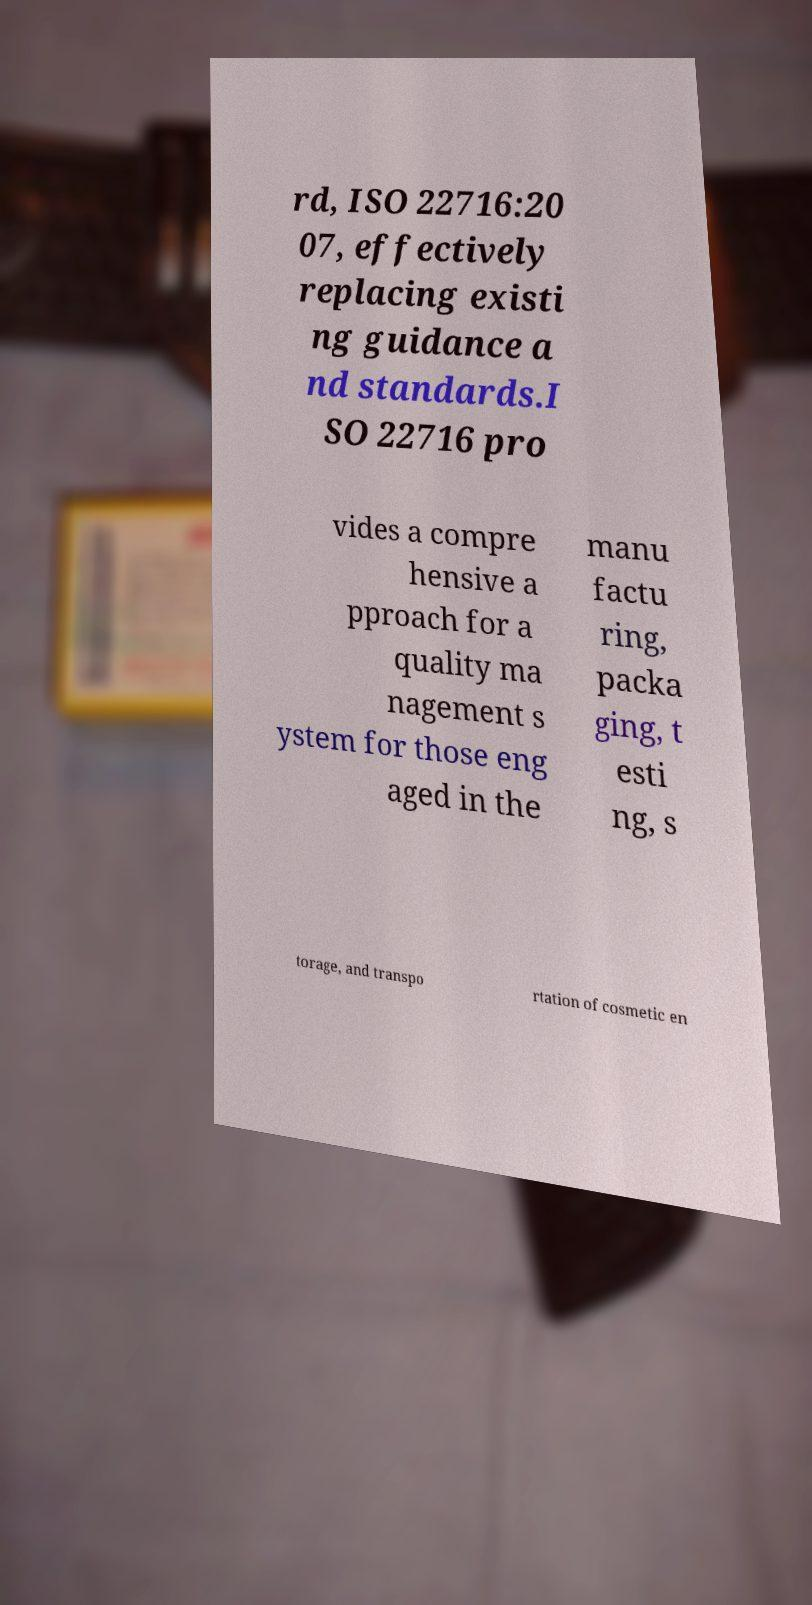Can you accurately transcribe the text from the provided image for me? rd, ISO 22716:20 07, effectively replacing existi ng guidance a nd standards.I SO 22716 pro vides a compre hensive a pproach for a quality ma nagement s ystem for those eng aged in the manu factu ring, packa ging, t esti ng, s torage, and transpo rtation of cosmetic en 